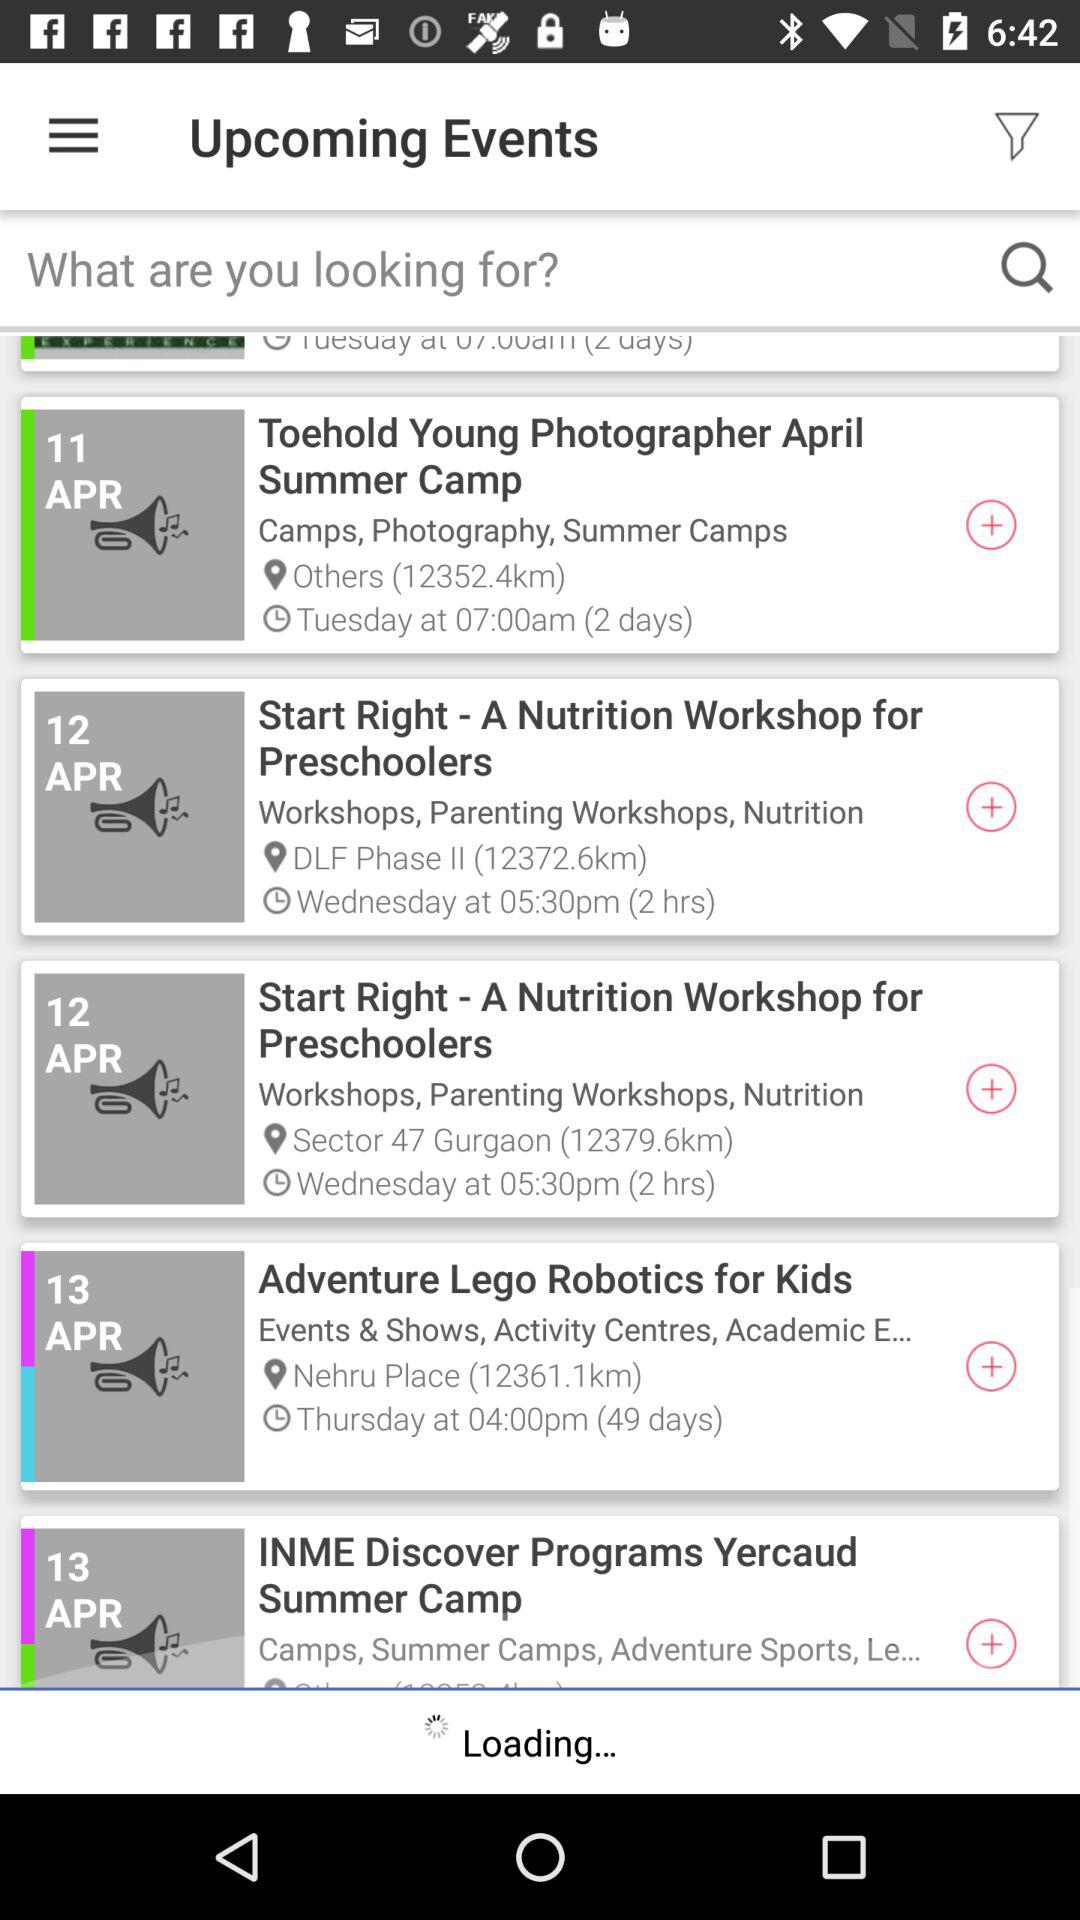What is the location of the event "Start Right - A Nutrition Workshop for Preschoolers"? The location is DLF Phase II. 